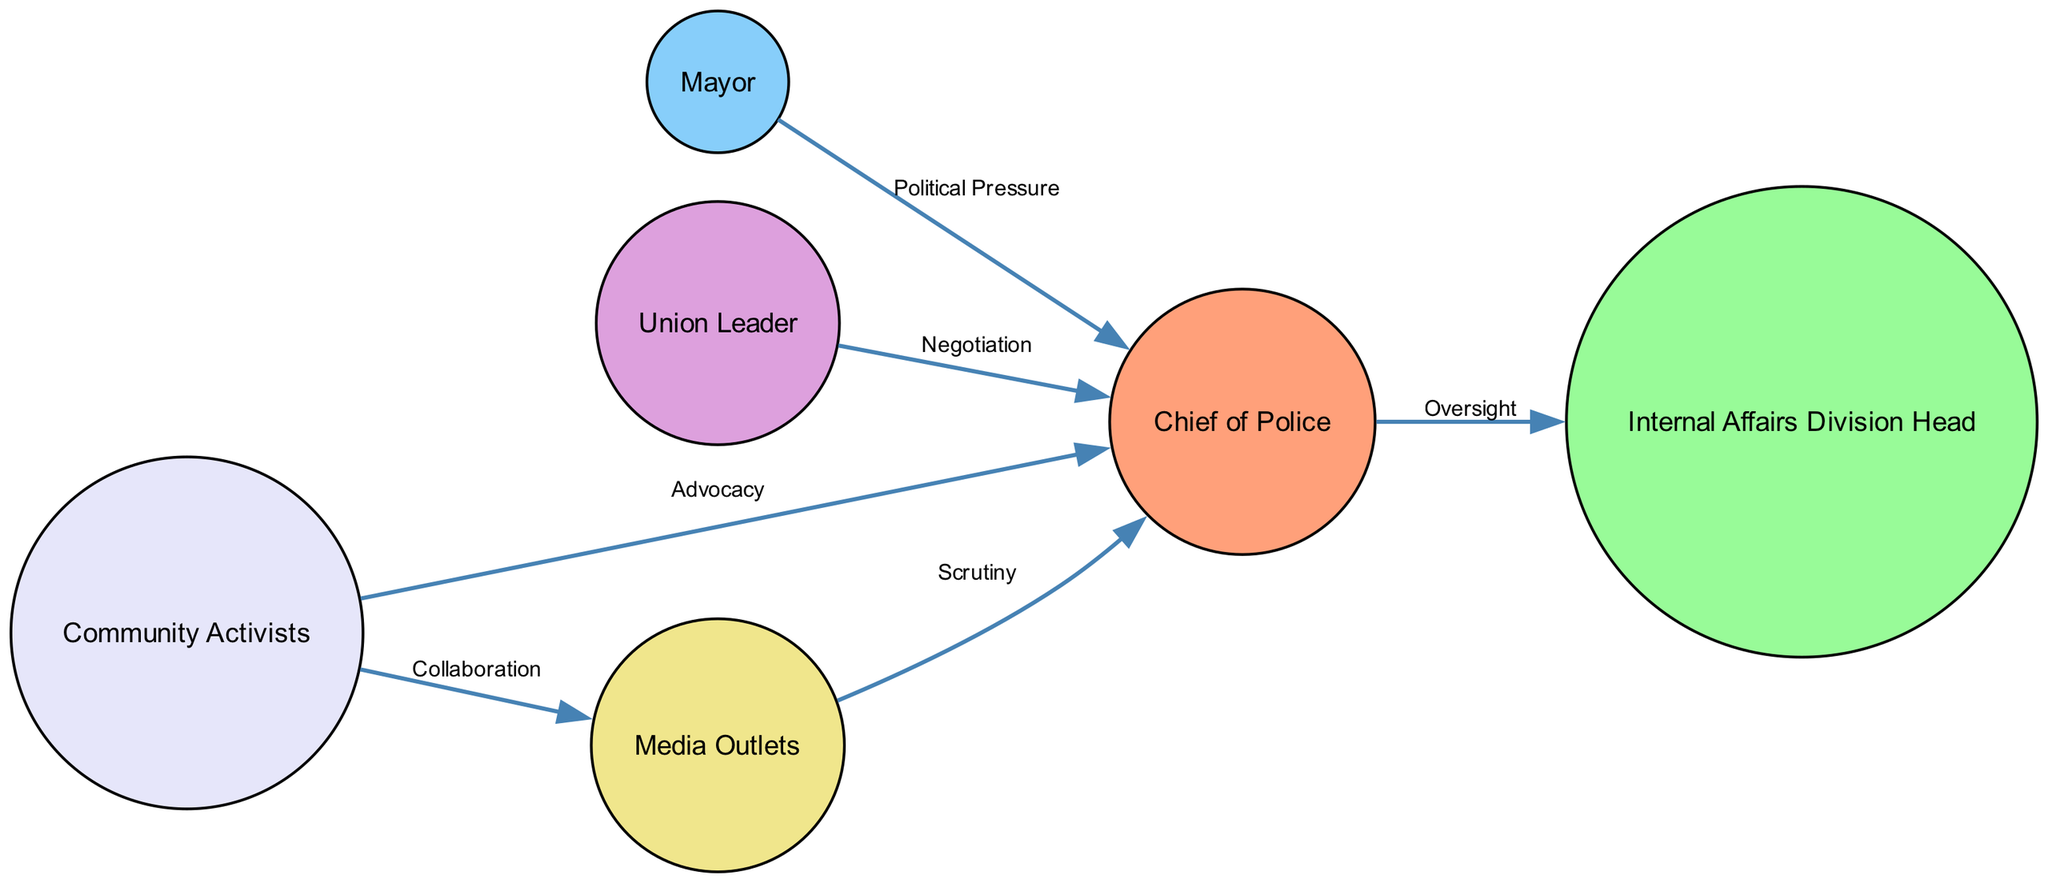What is the central figure in the diagram? The central figure is the "Chief of Police," as indicated in the diagram where this node is positioned prominently, surrounded by other related nodes representing key figures in the agency.
Answer: Chief of Police How many nodes are there in total? Counting the nodes listed in the diagram, there are six distinct entities represented, each playing a role in the overall influence structure of the agency.
Answer: 6 What relationship exists between the Chief of Police and the Internal Affairs Division Head? The relationship is defined as "Oversight," indicating that the Chief of Police has a supervisory role over the Internal Affairs Division Head, ensuring accountability within the agency.
Answer: Oversight Who exerts political pressure on the Chief of Police? The "Mayor" is the individual identified as exerting political pressure, as shown by the direct connection in the diagram that labels the relationship accordingly.
Answer: Mayor What two entities collaborate according to the diagram? The diagram indicates that "Community Activists" and "Media Outlets" are two entities that collaborate, reflecting a shared interest in influencing agency policies and transparency.
Answer: Community Activists and Media Outlets What is the relationship between the Union Leader and the Chief of Police? The relationship is labeled as "Negotiation," suggestive of interactions aimed at reaching agreements or settling disputes regarding officer interests within the agency.
Answer: Negotiation How many edges are depicted in the diagram? By analyzing the connections drawn between nodes, there are a total of six edges that represent the various relationships and interactions among the key figures outlined.
Answer: 6 What key advocacy role is attributed to Community Activists? Community Activists advocate for "transparency and reform," highlighting their role in pushing for changes and greater accountability within the agency.
Answer: Transparency and reform Which node is primarily responsible for shaping public perception? The "Media Outlets" node is primarily responsible for shaping public perception, as it is networked to other figures while highlighting its intelligence-gathering and broadcasting function in the diagram.
Answer: Media Outlets 